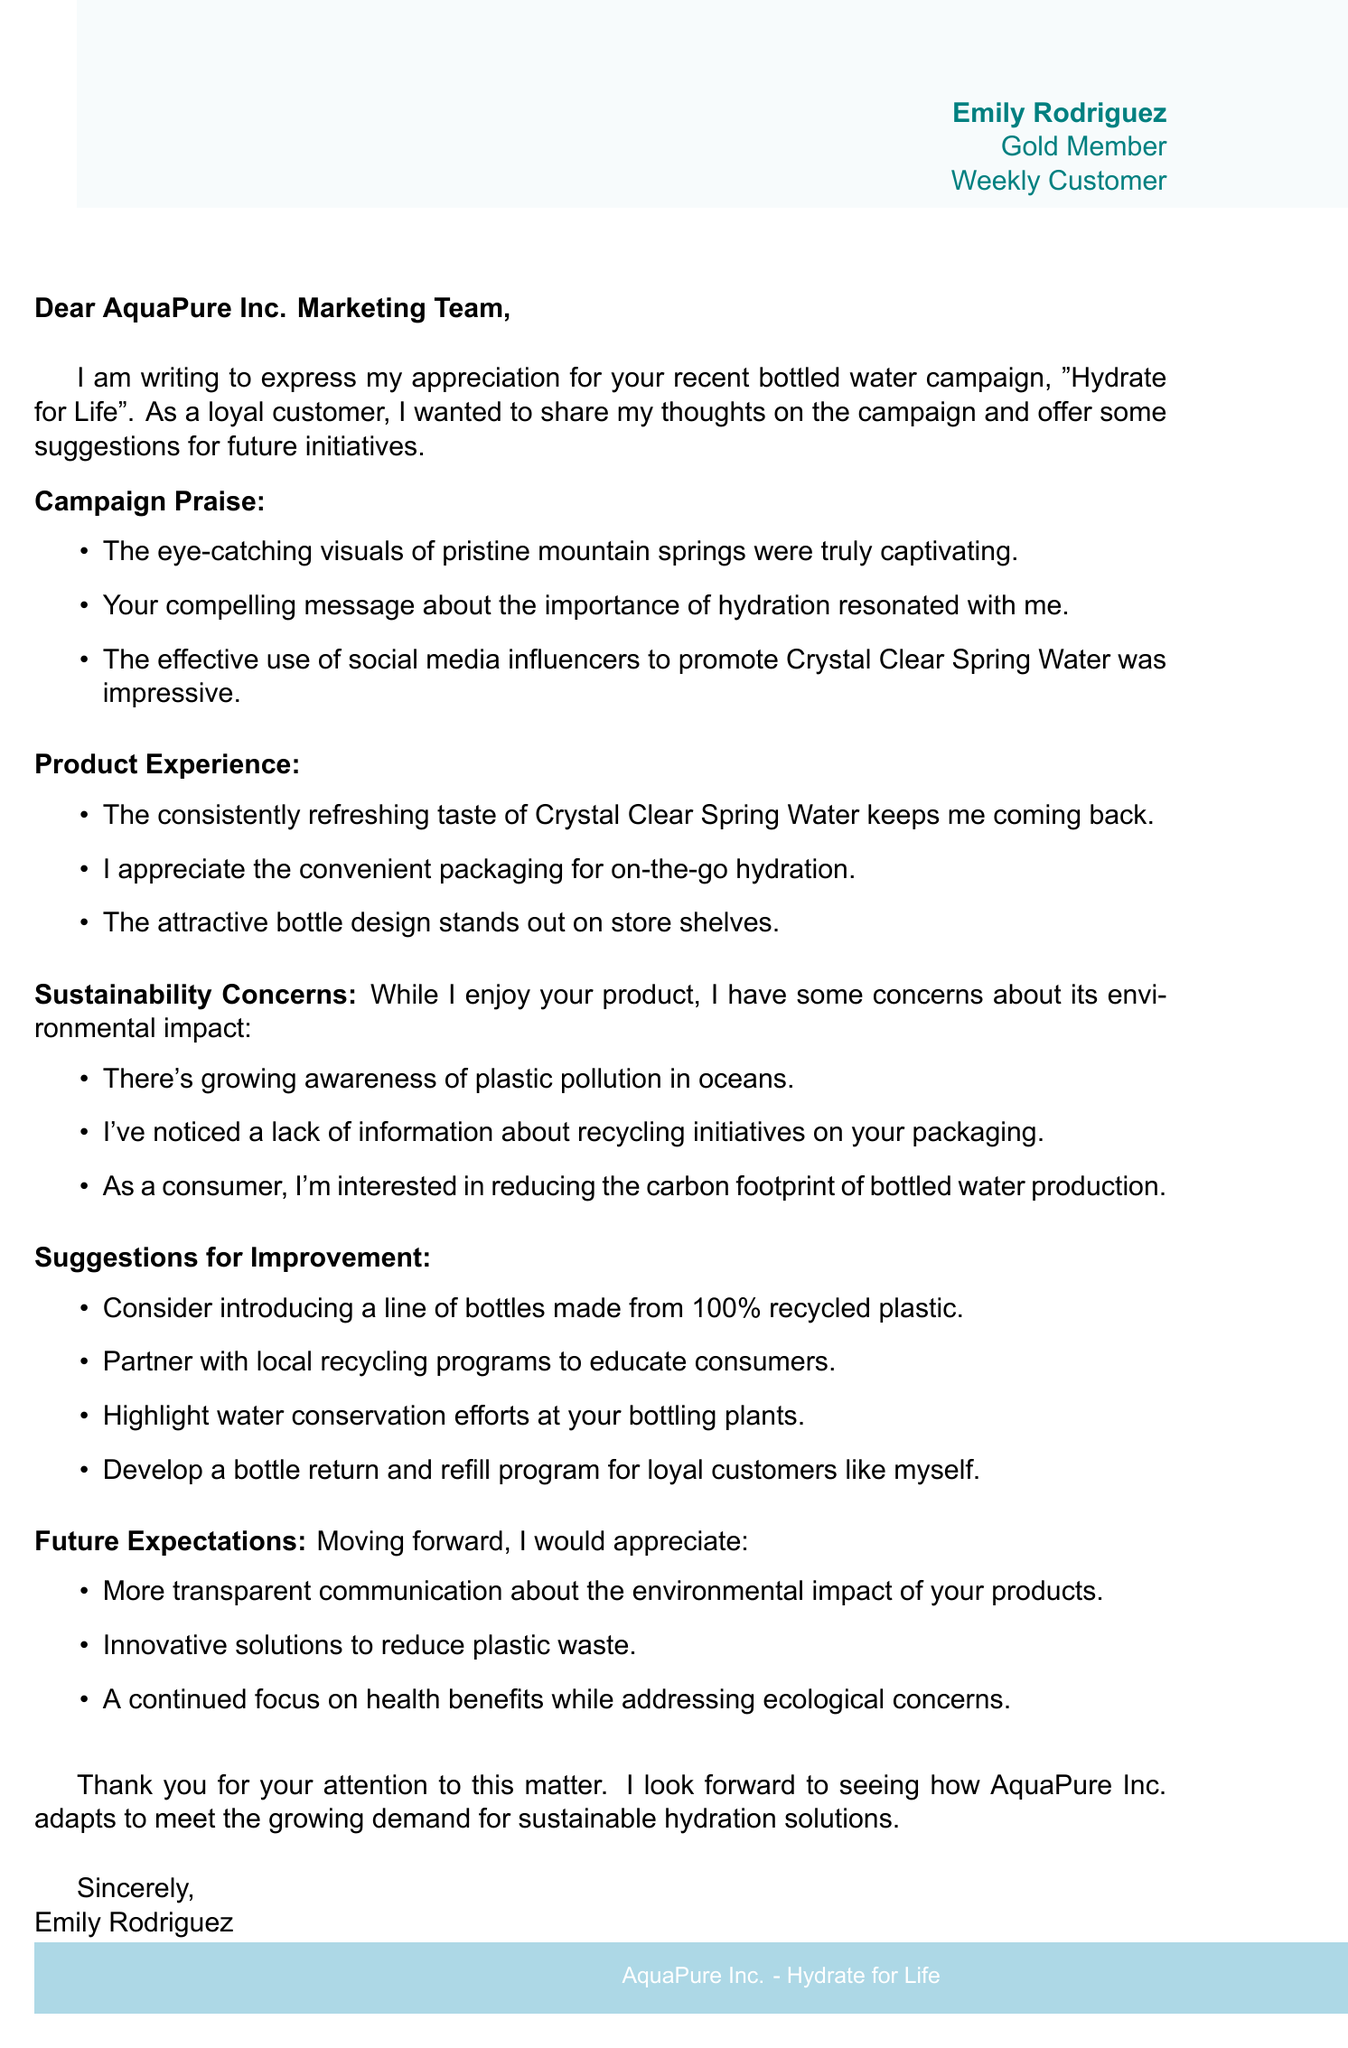What is the name of the company? The company name is mentioned in the salutation of the letter.
Answer: AquaPure Inc What is the name of the recent campaign? The recent campaign is highlighted in the opening of the letter.
Answer: Hydrate for Life Who is the customer that wrote the letter? The customer's name is provided in the signature section of the letter.
Answer: Emily Rodriguez What are the customer’s suggestions for improvement? The suggestions for improvement are listed in a specific section of the document.
Answer: Introduce a line of bottles made from 100% recycled plastic How often does the customer purchase the product? The purchase frequency is stated in the customer details section.
Answer: Weekly What environmental concern is mentioned regarding bottled water? The correspondence struggles with a specific concern mentioned in the sustainability concerns section.
Answer: Plastic pollution in oceans What is one of the future expectations mentioned by the customer? The expectations for future communication are specified in the future expectations section.
Answer: More transparent communication about the environmental impact What loyalty status does the customer have? The loyalty status is included in the customer details at the top of the document.
Answer: Gold Member What is the product discussed in the letter? The product is referenced multiple times throughout the letter.
Answer: Crystal Clear Spring Water 